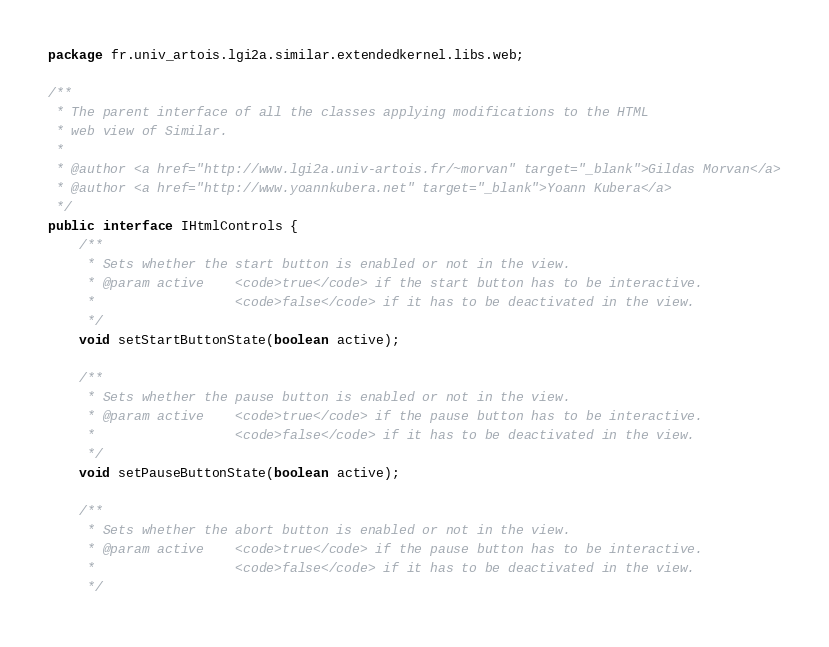<code> <loc_0><loc_0><loc_500><loc_500><_Java_>package fr.univ_artois.lgi2a.similar.extendedkernel.libs.web;

/**
 * The parent interface of all the classes applying modifications to the HTML 
 * web view of Similar.
 * 
 * @author <a href="http://www.lgi2a.univ-artois.fr/~morvan" target="_blank">Gildas Morvan</a>
 * @author <a href="http://www.yoannkubera.net" target="_blank">Yoann Kubera</a>
 */
public interface IHtmlControls {
	/**
	 * Sets whether the start button is enabled or not in the view.
	 * @param active 	<code>true</code> if the start button has to be interactive. 
	 * 					<code>false</code> if it has to be deactivated in the view.
	 */
	void setStartButtonState(boolean active);

	/**
	 * Sets whether the pause button is enabled or not in the view.
	 * @param active 	<code>true</code> if the pause button has to be interactive. 
	 * 					<code>false</code> if it has to be deactivated in the view.
	 */
	void setPauseButtonState(boolean active);

	/**
	 * Sets whether the abort button is enabled or not in the view.
	 * @param active 	<code>true</code> if the pause button has to be interactive. 
	 * 					<code>false</code> if it has to be deactivated in the view.
	 */</code> 